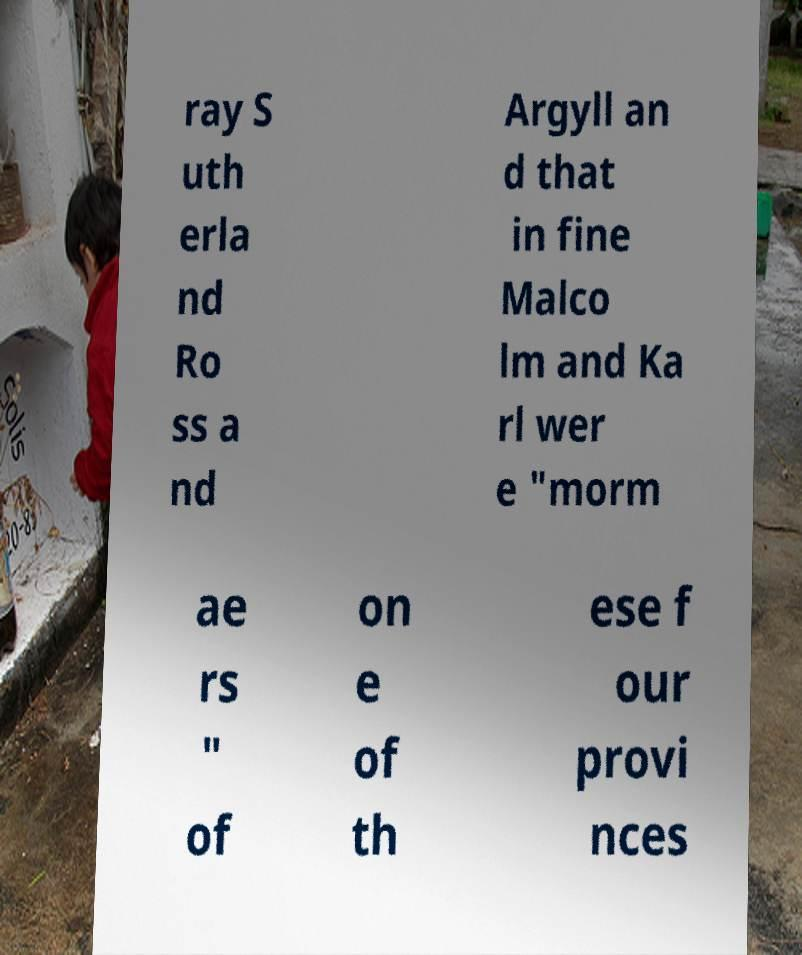Can you read and provide the text displayed in the image?This photo seems to have some interesting text. Can you extract and type it out for me? ray S uth erla nd Ro ss a nd Argyll an d that in fine Malco lm and Ka rl wer e "morm ae rs " of on e of th ese f our provi nces 